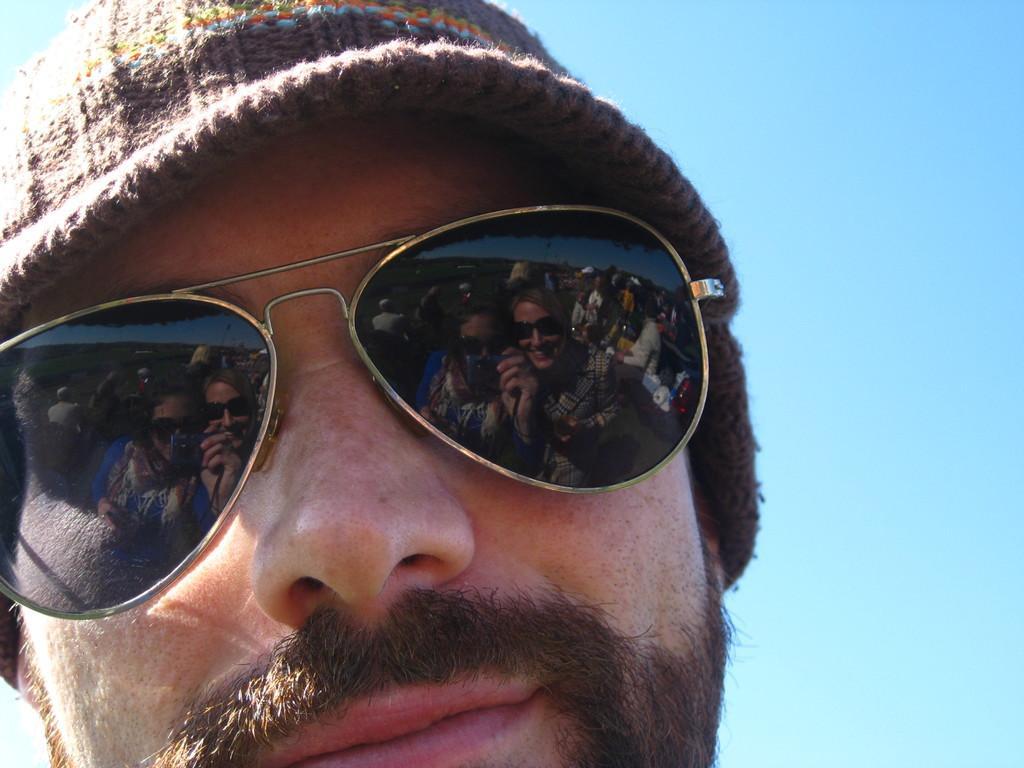In one or two sentences, can you explain what this image depicts? In this image, we can see a man wearing goggles and a hat. We can see the blue sky. 